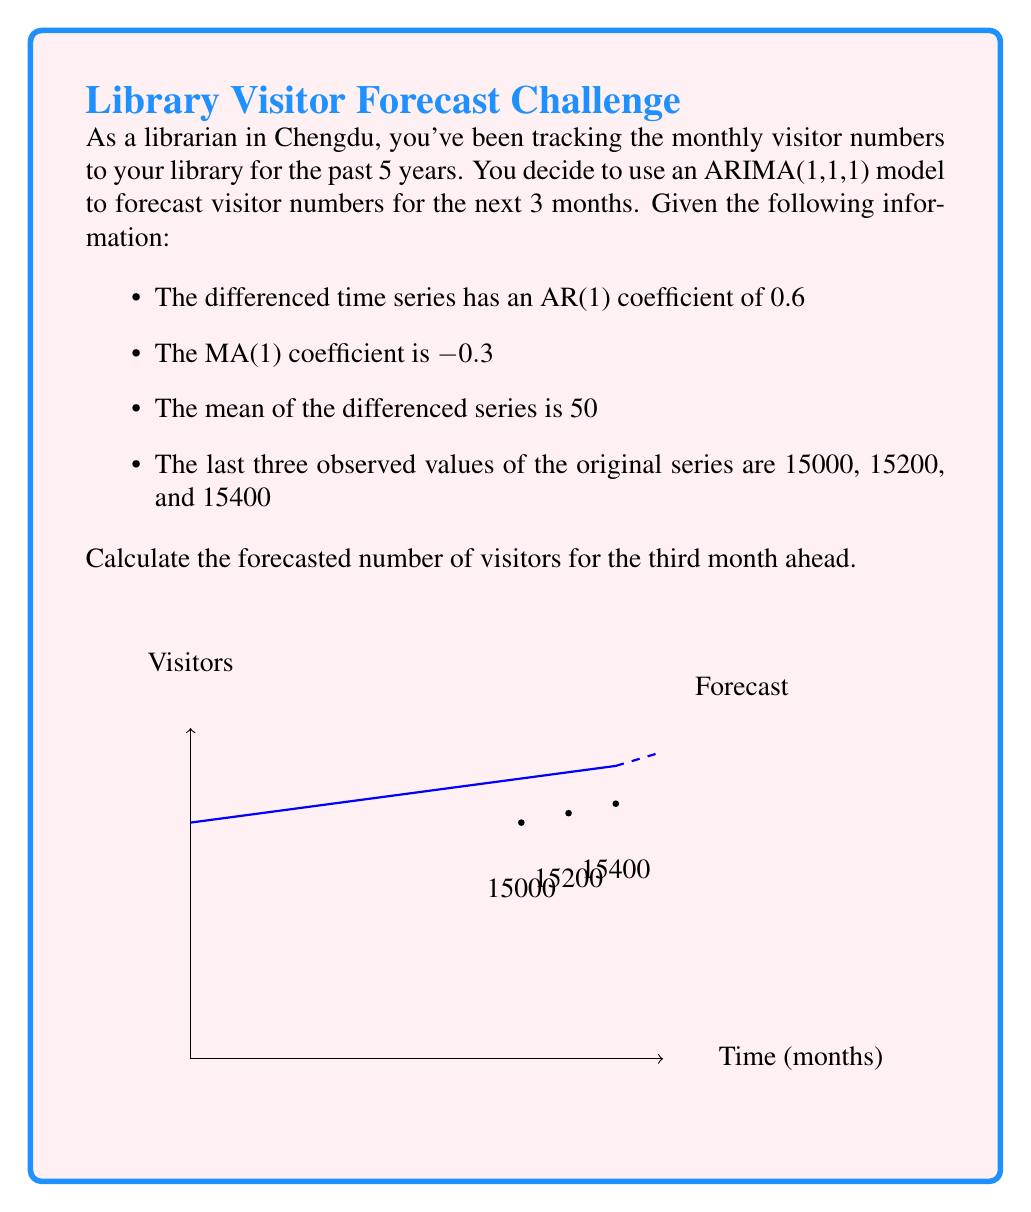Can you solve this math problem? Let's approach this step-by-step using the ARIMA(1,1,1) model:

1) The general form of an ARIMA(1,1,1) model for the differenced series is:

   $$(1-B)(1-\phi B)Y_t = (1-\theta B)\epsilon_t + c$$

   where $B$ is the backshift operator, $\phi$ is the AR(1) coefficient, $\theta$ is the MA(1) coefficient, and $c$ is a constant.

2) Given:
   - AR(1) coefficient $\phi = 0.6$
   - MA(1) coefficient $\theta = -0.3$
   - Mean of the differenced series $E[(1-B)Y_t] = 50$

3) The constant $c$ in the model is related to the mean of the differenced series:

   $$c = (1-\phi)E[(1-B)Y_t] = (1-0.6)(50) = 20$$

4) For forecasting, we use the following equation:

   $$\hat{Y}_{T+h} = Y_T + \sum_{i=1}^h \hat{y}_{T+i}$$

   where $\hat{y}_{T+i}$ are the forecasts for the differenced series.

5) For the differenced series, the forecast equation is:

   $$\hat{y}_{T+h} = \phi \hat{y}_{T+h-1} + c$$

   For $h > 1$, $\hat{y}_{T+h-1}$ is replaced by its forecast.

6) Calculate the forecasts for the differenced series:
   
   $\hat{y}_{T+1} = 0.6(15400 - 15200) + 20 = 140$
   
   $\hat{y}_{T+2} = 0.6(140) + 20 = 104$
   
   $\hat{y}_{T+3} = 0.6(104) + 20 = 82.4$

7) Now, calculate the forecast for the original series:

   $$\hat{Y}_{T+3} = Y_T + \hat{y}_{T+1} + \hat{y}_{T+2} + \hat{y}_{T+3}$$
   
   $$\hat{Y}_{T+3} = 15400 + 140 + 104 + 82.4 = 15726.4$$

Therefore, the forecasted number of visitors for the third month ahead is approximately 15,726.
Answer: 15,726 visitors 